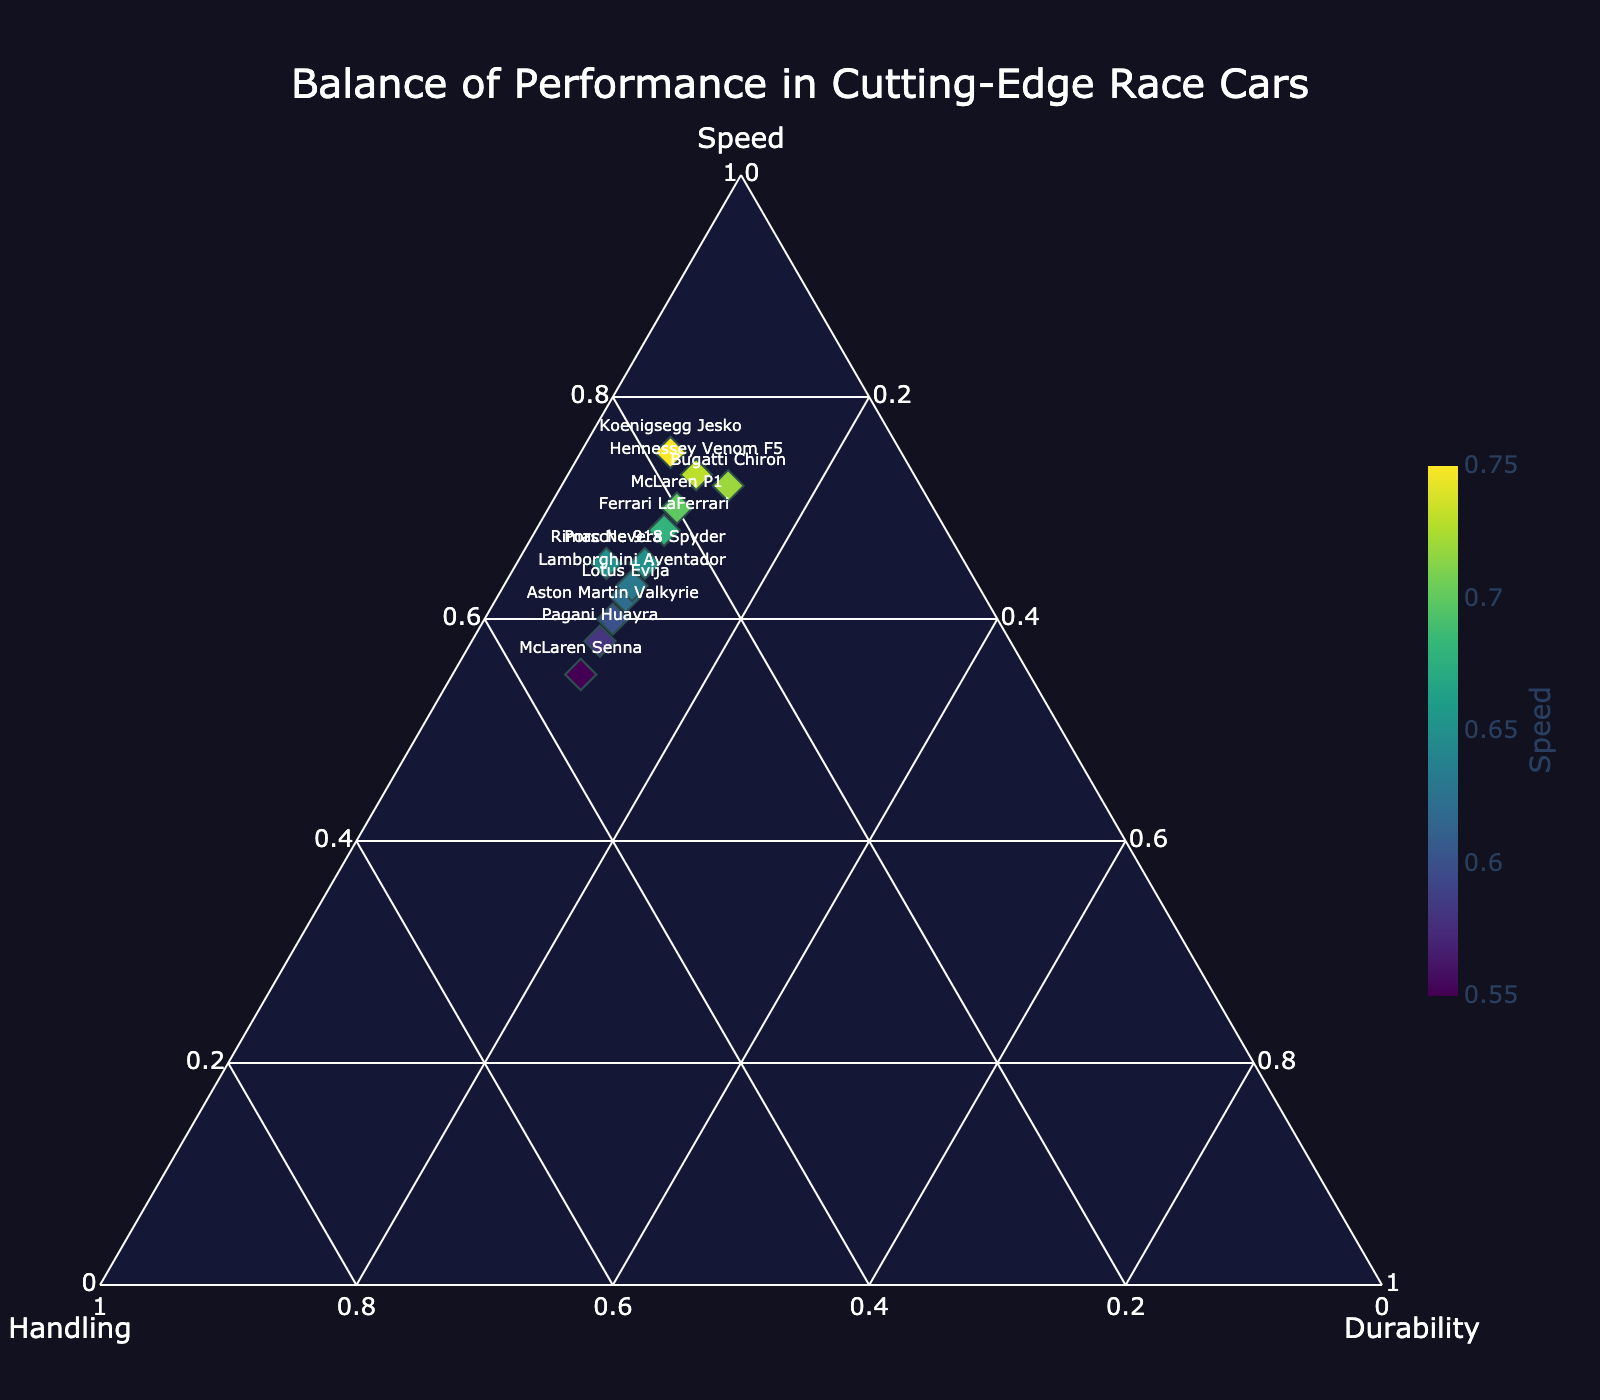What is the title of the figure? The title typically appears at the top of the figure. In this case, it reads "Balance of Performance in Cutting-Edge Race Cars".
Answer: Balance of Performance in Cutting-Edge Race Cars Which axis represents "Handling"? In a Ternary Plot, each corner or axis represents one of the attributes. According to the problem, "Handling" is labeled on one of the three axes.
Answer: One of the three axes How many data points are represented on the Ternary Plot? Each car model constitutes a data point. By counting the car models listed in the provided data, there are 12 data points in the plot.
Answer: 12 Which car model has the highest normalized speed value? The car model with the highest normalized speed value is represented closest to the "Speed" corner of the Ternary Plot. Among the provided cars, the Koenigsegg Jesko has the highest speed value.
Answer: Koenigsegg Jesko Do any car models have equal values for all three attributes? In a Ternary Plot, equal values for all three attributes would place the point exactly in the center. Here, no car model possesses equal values for Speed, Handling, and Durability.
Answer: No Which car model has the best balance between Handling and Durability? Look at the data points closest to the line connecting the Handling and Durability corners. The car model that balances Handling and Durability best, without leaning too much towards Speed, is the McLaren Senna, as it has relatively high Handling.
Answer: McLaren Senna What is the average normalized value for Handling across all car models? Normalize the Handling values and calculate the average. Sum the normalized Handling values and divide by the number of car models: 0.25+0.20+0.22+0.18+0.15+0.30+0.28+0.28+0.17+0.32+0.35+0.27 = 2.97. The average is 2.97/12.
Answer: 0.2475 Which car model has the highest combination of Speed and Handling? Identify the car with the highest combined value of Speed and Handling. Add Speed and Handling for each car and compare the sums: Koenigsegg Jesko has the highest combined value with 0.75 (Speed) + 0.18 (Handling).
Answer: Koenigsegg Jesko Among the cars having a Durability value of 0.10, which car model has the highest Handling? Filter the cars with a Durability value of 0.10 and compare their Handling values: Pagani Huayra has the highest Handling of 0.32 among those with Durability of 0.10.
Answer: Pagani Huayra 